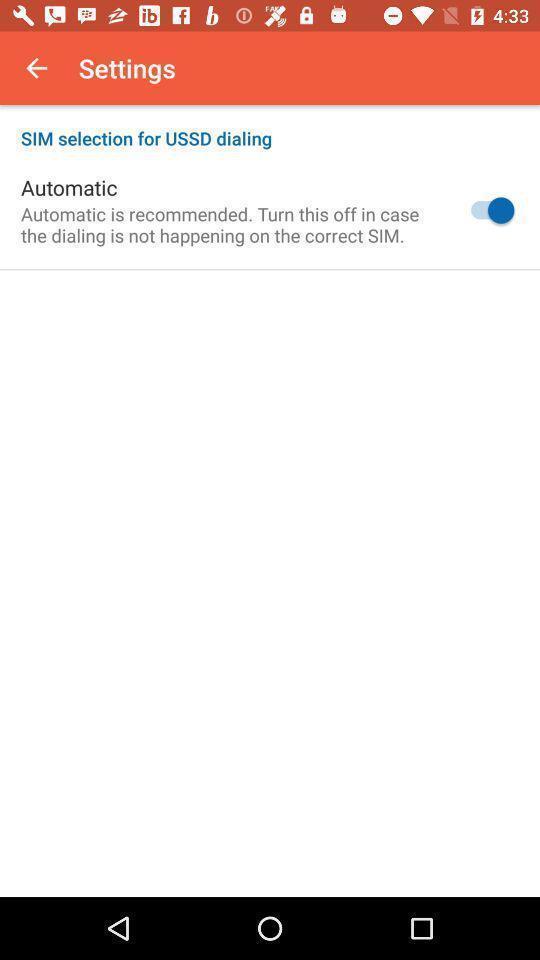Tell me about the visual elements in this screen capture. Settings page. 